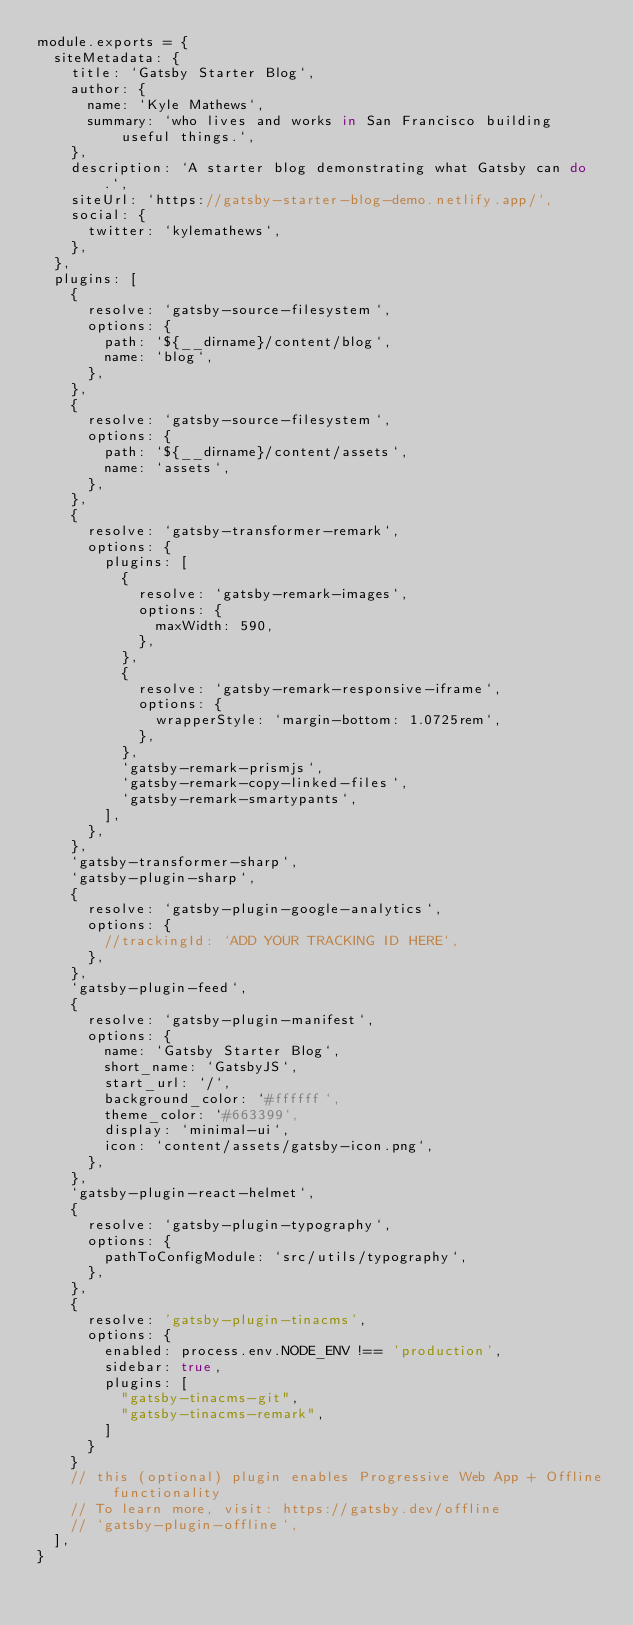Convert code to text. <code><loc_0><loc_0><loc_500><loc_500><_JavaScript_>module.exports = {
  siteMetadata: {
    title: `Gatsby Starter Blog`,
    author: {
      name: `Kyle Mathews`,
      summary: `who lives and works in San Francisco building useful things.`,
    },
    description: `A starter blog demonstrating what Gatsby can do.`,
    siteUrl: `https://gatsby-starter-blog-demo.netlify.app/`,
    social: {
      twitter: `kylemathews`,
    },
  },
  plugins: [
    {
      resolve: `gatsby-source-filesystem`,
      options: {
        path: `${__dirname}/content/blog`,
        name: `blog`,
      },
    },
    {
      resolve: `gatsby-source-filesystem`,
      options: {
        path: `${__dirname}/content/assets`,
        name: `assets`,
      },
    },
    {
      resolve: `gatsby-transformer-remark`,
      options: {
        plugins: [
          {
            resolve: `gatsby-remark-images`,
            options: {
              maxWidth: 590,
            },
          },
          {
            resolve: `gatsby-remark-responsive-iframe`,
            options: {
              wrapperStyle: `margin-bottom: 1.0725rem`,
            },
          },
          `gatsby-remark-prismjs`,
          `gatsby-remark-copy-linked-files`,
          `gatsby-remark-smartypants`,
        ],
      },
    },
    `gatsby-transformer-sharp`,
    `gatsby-plugin-sharp`,
    {
      resolve: `gatsby-plugin-google-analytics`,
      options: {
        //trackingId: `ADD YOUR TRACKING ID HERE`,
      },
    },
    `gatsby-plugin-feed`,
    {
      resolve: `gatsby-plugin-manifest`,
      options: {
        name: `Gatsby Starter Blog`,
        short_name: `GatsbyJS`,
        start_url: `/`,
        background_color: `#ffffff`,
        theme_color: `#663399`,
        display: `minimal-ui`,
        icon: `content/assets/gatsby-icon.png`,
      },
    },
    `gatsby-plugin-react-helmet`,
    {
      resolve: `gatsby-plugin-typography`,
      options: {
        pathToConfigModule: `src/utils/typography`,
      },
    },
    {
      resolve: 'gatsby-plugin-tinacms',
      options: {
        enabled: process.env.NODE_ENV !== 'production',
        sidebar: true,
        plugins: [
          "gatsby-tinacms-git",
          "gatsby-tinacms-remark",
        ]
      }
    }
    // this (optional) plugin enables Progressive Web App + Offline functionality
    // To learn more, visit: https://gatsby.dev/offline
    // `gatsby-plugin-offline`,
  ],
}
</code> 